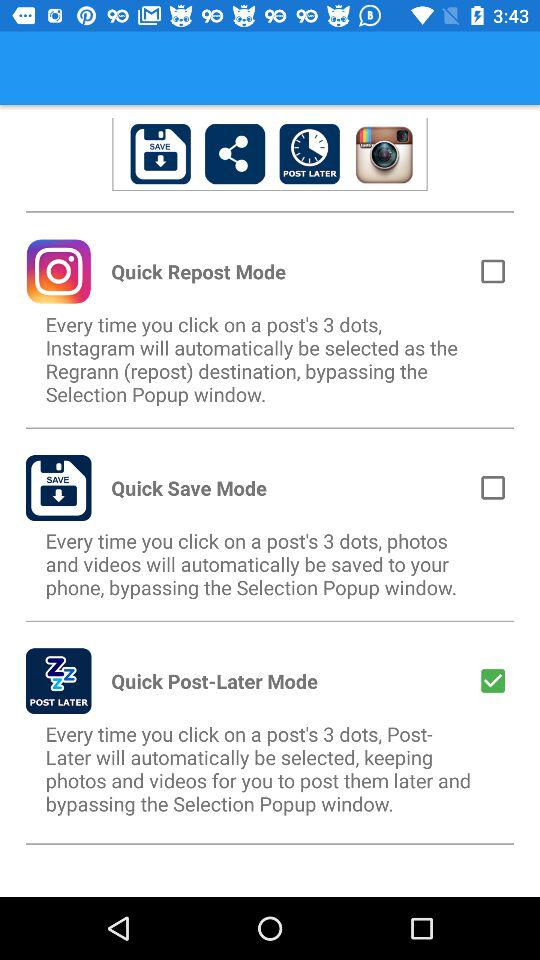Who developed these applications?
When the provided information is insufficient, respond with <no answer>. <no answer> 